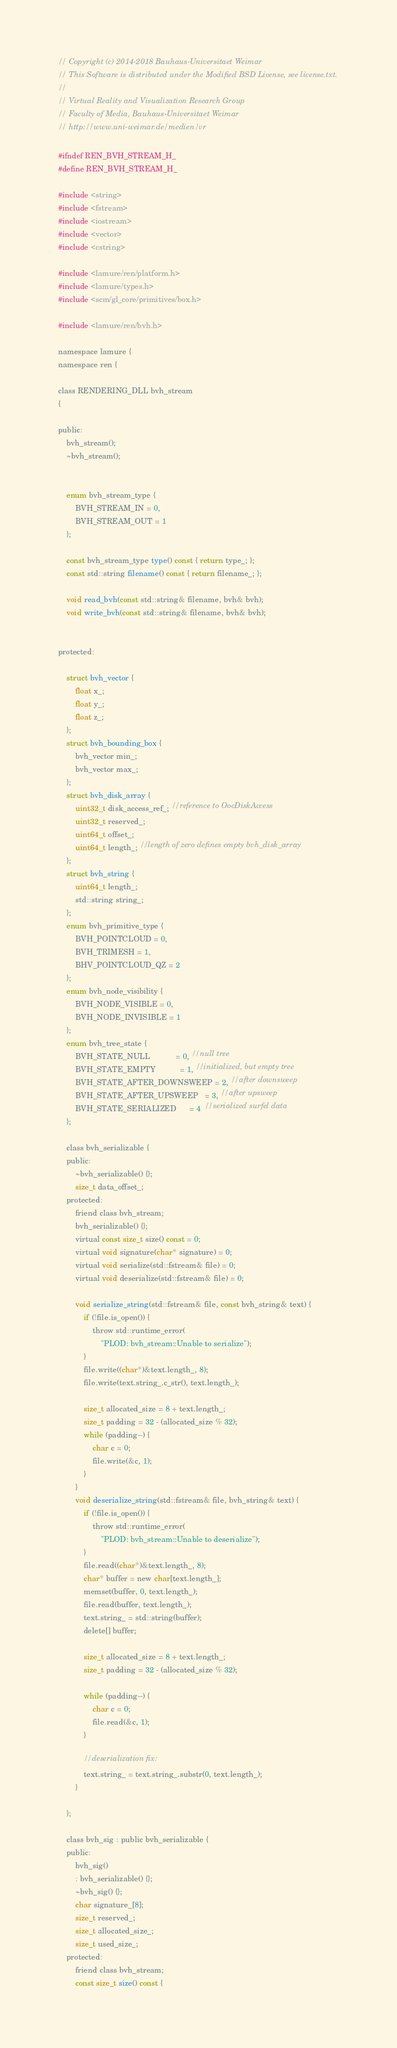<code> <loc_0><loc_0><loc_500><loc_500><_C_>// Copyright (c) 2014-2018 Bauhaus-Universitaet Weimar
// This Software is distributed under the Modified BSD License, see license.txt.
//
// Virtual Reality and Visualization Research Group 
// Faculty of Media, Bauhaus-Universitaet Weimar
// http://www.uni-weimar.de/medien/vr

#ifndef REN_BVH_STREAM_H_
#define REN_BVH_STREAM_H_

#include <string>
#include <fstream>
#include <iostream>
#include <vector>
#include <cstring>

#include <lamure/ren/platform.h>
#include <lamure/types.h>
#include <scm/gl_core/primitives/box.h>

#include <lamure/ren/bvh.h>

namespace lamure {
namespace ren {

class RENDERING_DLL bvh_stream
{

public:
    bvh_stream();
    ~bvh_stream();


    enum bvh_stream_type {
        BVH_STREAM_IN = 0,
        BVH_STREAM_OUT = 1
    };

    const bvh_stream_type type() const { return type_; };
    const std::string filename() const { return filename_; };

    void read_bvh(const std::string& filename, bvh& bvh);
    void write_bvh(const std::string& filename, bvh& bvh);


protected:

    struct bvh_vector {
        float x_;
        float y_;
        float z_;
    };
    struct bvh_bounding_box {
        bvh_vector min_;
        bvh_vector max_;
    };
    struct bvh_disk_array {
        uint32_t disk_access_ref_; //reference to OocDiskAccess
        uint32_t reserved_;
        uint64_t offset_;
        uint64_t length_; //length of zero defines empty bvh_disk_array
    };
    struct bvh_string {
        uint64_t length_;
        std::string string_;
    };
    enum bvh_primitive_type {
        BVH_POINTCLOUD = 0,
        BVH_TRIMESH = 1,
        BHV_POINTCLOUD_QZ = 2
    };
    enum bvh_node_visibility {
        BVH_NODE_VISIBLE = 0,
        BVH_NODE_INVISIBLE = 1
    };
    enum bvh_tree_state {
        BVH_STATE_NULL            = 0, //null tree
        BVH_STATE_EMPTY           = 1, //initialized, but empty tree
        BVH_STATE_AFTER_DOWNSWEEP = 2, //after downsweep
        BVH_STATE_AFTER_UPSWEEP   = 3, //after upsweep
        BVH_STATE_SERIALIZED      = 4  //serialized surfel data
    };
  
    class bvh_serializable {
    public:
        ~bvh_serializable() {};
        size_t data_offset_;
    protected:
        friend class bvh_stream;
        bvh_serializable() {};
        virtual const size_t size() const = 0;
        virtual void signature(char* signature) = 0;
        virtual void serialize(std::fstream& file) = 0;
        virtual void deserialize(std::fstream& file) = 0;

        void serialize_string(std::fstream& file, const bvh_string& text) {
            if (!file.is_open()) {
                throw std::runtime_error(
                    "PLOD: bvh_stream::Unable to serialize");
            }
            file.write((char*)&text.length_, 8);
            file.write(text.string_.c_str(), text.length_);

            size_t allocated_size = 8 + text.length_;
            size_t padding = 32 - (allocated_size % 32);
            while (padding--) {
                char c = 0;
                file.write(&c, 1);
            }
        }
        void deserialize_string(std::fstream& file, bvh_string& text) {
            if (!file.is_open()) {
                throw std::runtime_error(
                    "PLOD: bvh_stream::Unable to deserialize");
            }
            file.read((char*)&text.length_, 8);
            char* buffer = new char[text.length_];
            memset(buffer, 0, text.length_);
            file.read(buffer, text.length_);
            text.string_ = std::string(buffer);
            delete[] buffer;
            
            size_t allocated_size = 8 + text.length_;
            size_t padding = 32 - (allocated_size % 32);

            while (padding--) {
                char c = 0;
                file.read(&c, 1);
            }
            
            //deserialization fix:
            text.string_ = text.string_.substr(0, text.length_);
        }

    };

    class bvh_sig : public bvh_serializable {
    public:
        bvh_sig()
        : bvh_serializable() {};
        ~bvh_sig() {};
        char signature_[8];
        size_t reserved_;
        size_t allocated_size_;
        size_t used_size_;
    protected:
        friend class bvh_stream;
        const size_t size() const {</code> 